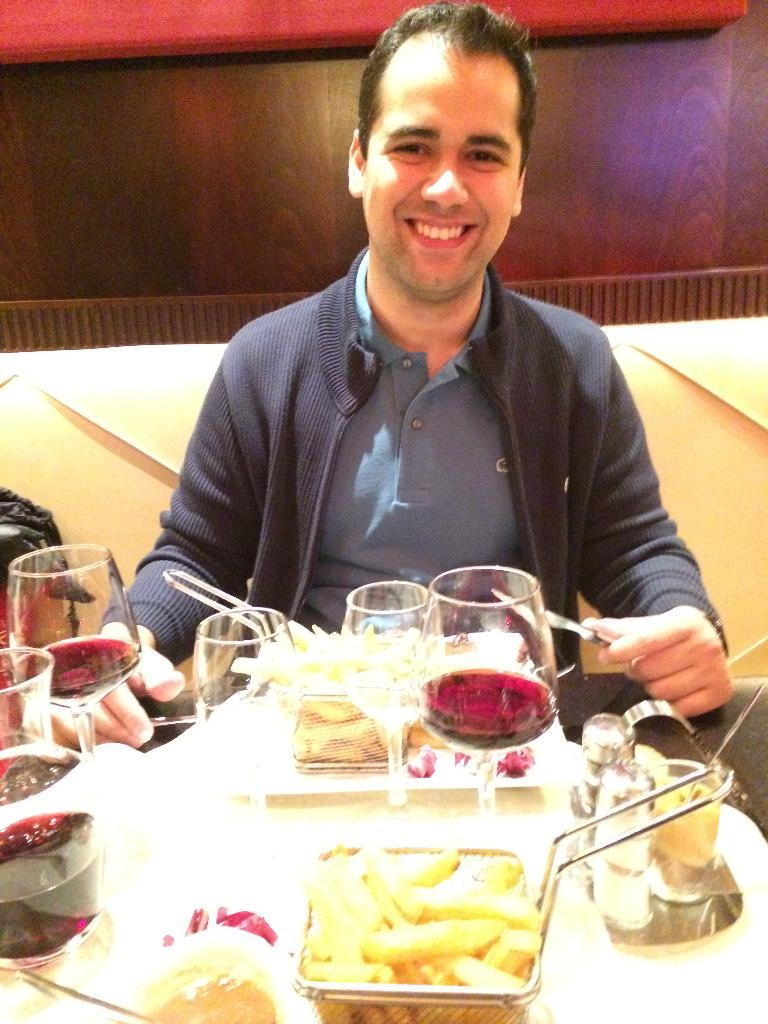What is the man doing in the image? The man is sitting on a sofa. What expression does the man have? The man is smiling. What is the man holding in the image? The man is holding a spoon. What is in front of the man on the table? There are glasses and food in front of the man. What can be seen on the table? There are objects on the table. What is visible in the background of the image? There is a wall in the background. What type of memory does the man have in his hand in the image? There is no memory present in the image; the man is holding a spoon. What place is the man visiting in the image? The image does not depict the man visiting a specific place; he is sitting on a sofa. 